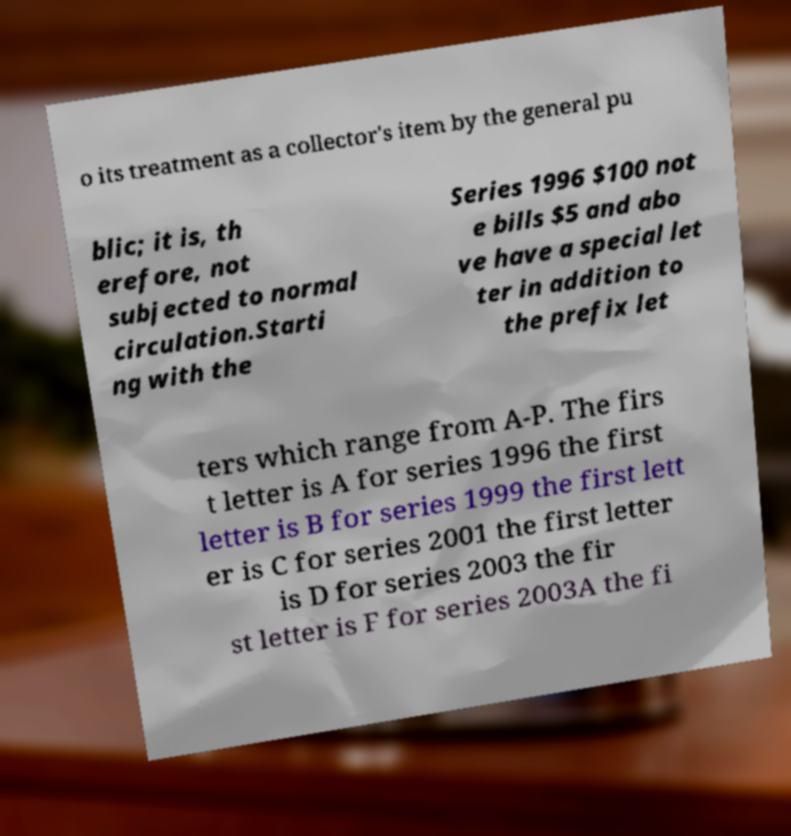I need the written content from this picture converted into text. Can you do that? o its treatment as a collector's item by the general pu blic; it is, th erefore, not subjected to normal circulation.Starti ng with the Series 1996 $100 not e bills $5 and abo ve have a special let ter in addition to the prefix let ters which range from A-P. The firs t letter is A for series 1996 the first letter is B for series 1999 the first lett er is C for series 2001 the first letter is D for series 2003 the fir st letter is F for series 2003A the fi 